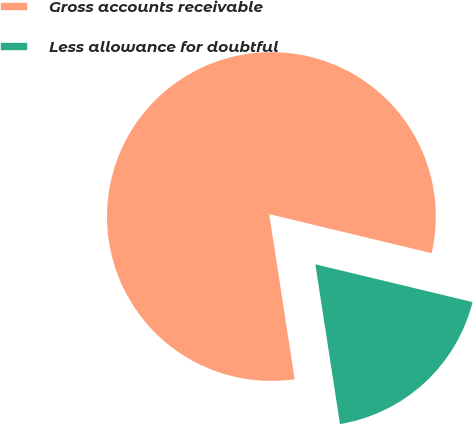Convert chart. <chart><loc_0><loc_0><loc_500><loc_500><pie_chart><fcel>Gross accounts receivable<fcel>Less allowance for doubtful<nl><fcel>81.19%<fcel>18.81%<nl></chart> 